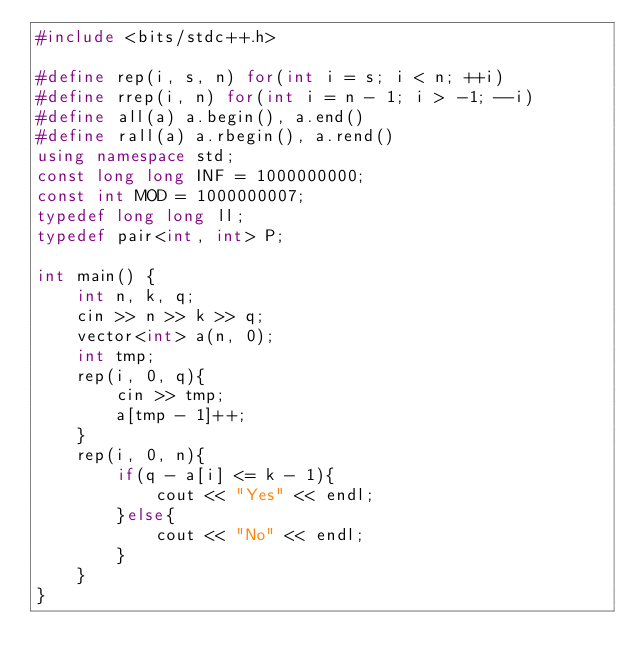<code> <loc_0><loc_0><loc_500><loc_500><_C++_>#include <bits/stdc++.h>

#define rep(i, s, n) for(int i = s; i < n; ++i)
#define rrep(i, n) for(int i = n - 1; i > -1; --i)
#define all(a) a.begin(), a.end()
#define rall(a) a.rbegin(), a.rend()
using namespace std;
const long long INF = 1000000000;
const int MOD = 1000000007;
typedef long long ll;
typedef pair<int, int> P;

int main() {
    int n, k, q;
    cin >> n >> k >> q;
    vector<int> a(n, 0);
    int tmp;
    rep(i, 0, q){
        cin >> tmp;
        a[tmp - 1]++;
    }
    rep(i, 0, n){
        if(q - a[i] <= k - 1){
            cout << "Yes" << endl;
        }else{
            cout << "No" << endl;
        }
    }
}
</code> 